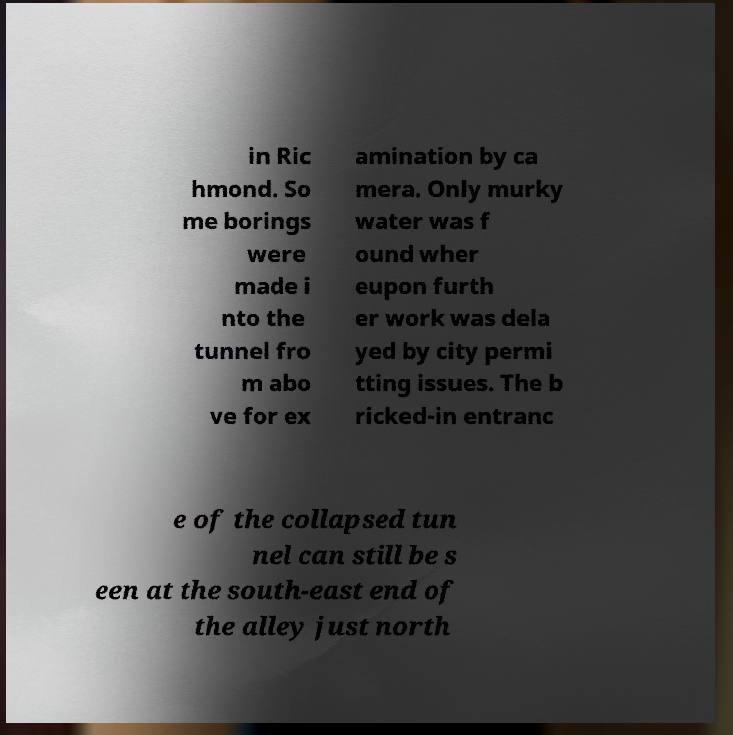Please read and relay the text visible in this image. What does it say? in Ric hmond. So me borings were made i nto the tunnel fro m abo ve for ex amination by ca mera. Only murky water was f ound wher eupon furth er work was dela yed by city permi tting issues. The b ricked-in entranc e of the collapsed tun nel can still be s een at the south-east end of the alley just north 